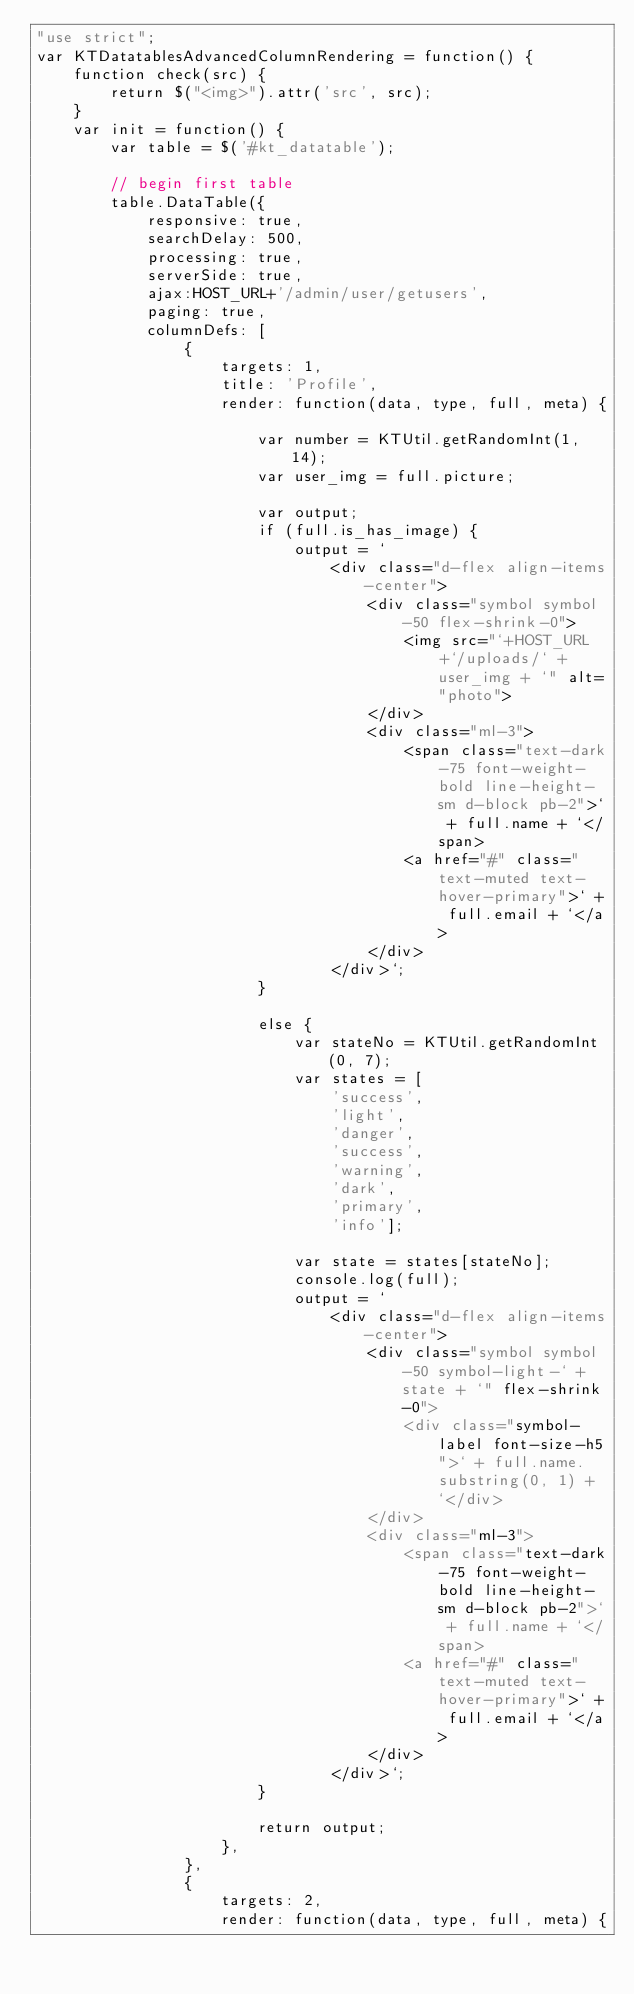<code> <loc_0><loc_0><loc_500><loc_500><_JavaScript_>"use strict";
var KTDatatablesAdvancedColumnRendering = function() {
    function check(src) {
        return $("<img>").attr('src', src);
    }
    var init = function() {
        var table = $('#kt_datatable');

        // begin first table
        table.DataTable({
            responsive: true,
            searchDelay: 500,
            processing: true,
            serverSide: true,
            ajax:HOST_URL+'/admin/user/getusers',
            paging: true,
            columnDefs: [
                {
                    targets: 1,
                    title: 'Profile',
                    render: function(data, type, full, meta) {

                        var number = KTUtil.getRandomInt(1, 14);
                        var user_img = full.picture;

                        var output;
                        if (full.is_has_image) {
                            output = `
                                <div class="d-flex align-items-center">
                                    <div class="symbol symbol-50 flex-shrink-0">
                                        <img src="`+HOST_URL+`/uploads/` + user_img + `" alt="photo">
                                    </div>
                                    <div class="ml-3">
                                        <span class="text-dark-75 font-weight-bold line-height-sm d-block pb-2">` + full.name + `</span>
                                        <a href="#" class="text-muted text-hover-primary">` + full.email + `</a>
                                    </div>
                                </div>`;
                        }

                        else {
                            var stateNo = KTUtil.getRandomInt(0, 7);
                            var states = [
                                'success',
                                'light',
                                'danger',
                                'success',
                                'warning',
                                'dark',
                                'primary',
                                'info'];

                            var state = states[stateNo];
                            console.log(full);
                            output = `
                                <div class="d-flex align-items-center">
                                    <div class="symbol symbol-50 symbol-light-` + state + `" flex-shrink-0">
                                        <div class="symbol-label font-size-h5">` + full.name.substring(0, 1) + `</div>
                                    </div>
                                    <div class="ml-3">
                                        <span class="text-dark-75 font-weight-bold line-height-sm d-block pb-2">` + full.name + `</span>
                                        <a href="#" class="text-muted text-hover-primary">` + full.email + `</a>
                                    </div>
                                </div>`;
                        }

                        return output;
                    },
                },
                {
                    targets: 2,
                    render: function(data, type, full, meta) {</code> 